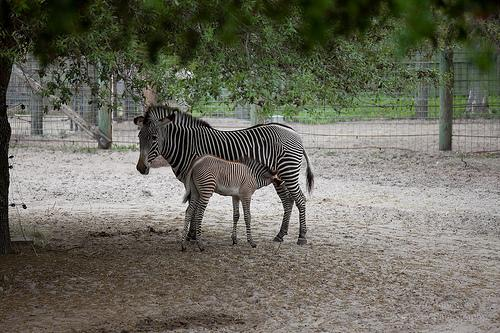State the condition of the tree in the image and the color of its components. The tree has dark brown bark and green leaves that are short. Mention any notable interaction between the animals in the image. The younger zebra is nursing from its mother, and the calf is suckling. What is the primary animal captured in the image and what are its unique features? The primary animal is a zebra, featuring black and white stripes, black nose, dark eyes, and black and white ears. Evaluate the sentiment or emotion conveyed by the image. The image conveys a sense of natural beauty and serene connection between the mother zebra and her calf in their outdoor habitat. Explain the outdoor scene in the image, and mention the time of day the photo was taken. The photo captures an outdoor scene during the day where zebras are standing under a tree, surrounded by a metallic fence on sandy ground. Analyze the relationship between the zebras and the surrounding environment. The zebras are standing on a brown sandy ground with footprints, under a tree with dark brown bark and green leaves, and are enclosed by a metallic fence. Quantitatively assess the components of the image by counting the number of zebras and major objects. There are two zebras, one tree with green leaves, one metallic fence, and the ground with brown sand and footprints. 